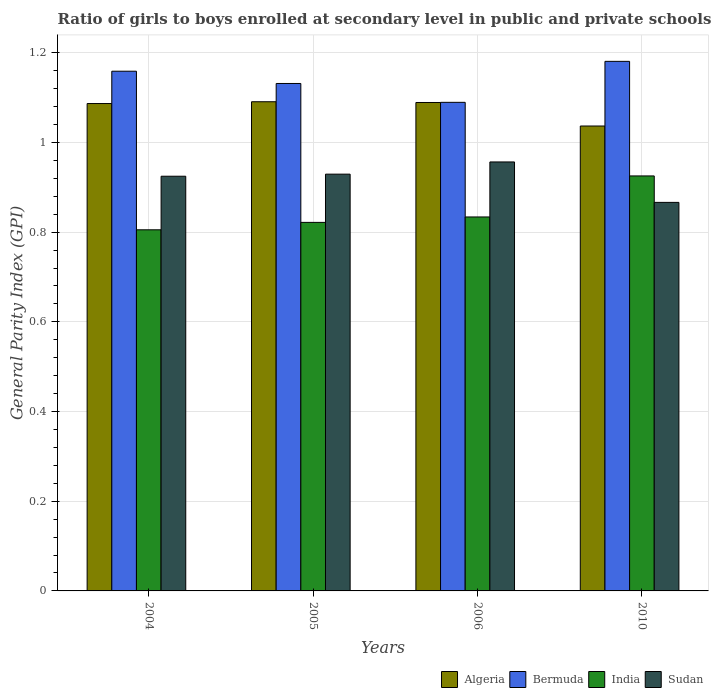How many groups of bars are there?
Offer a terse response. 4. Are the number of bars per tick equal to the number of legend labels?
Give a very brief answer. Yes. Are the number of bars on each tick of the X-axis equal?
Your answer should be very brief. Yes. How many bars are there on the 3rd tick from the left?
Give a very brief answer. 4. How many bars are there on the 1st tick from the right?
Keep it short and to the point. 4. What is the label of the 4th group of bars from the left?
Keep it short and to the point. 2010. In how many cases, is the number of bars for a given year not equal to the number of legend labels?
Keep it short and to the point. 0. What is the general parity index in India in 2010?
Make the answer very short. 0.93. Across all years, what is the maximum general parity index in India?
Provide a succinct answer. 0.93. Across all years, what is the minimum general parity index in Sudan?
Offer a very short reply. 0.87. In which year was the general parity index in Sudan maximum?
Your answer should be very brief. 2006. In which year was the general parity index in Sudan minimum?
Offer a very short reply. 2010. What is the total general parity index in India in the graph?
Provide a short and direct response. 3.39. What is the difference between the general parity index in Bermuda in 2005 and that in 2006?
Give a very brief answer. 0.04. What is the difference between the general parity index in Algeria in 2010 and the general parity index in Bermuda in 2005?
Provide a succinct answer. -0.09. What is the average general parity index in Sudan per year?
Offer a very short reply. 0.92. In the year 2010, what is the difference between the general parity index in India and general parity index in Bermuda?
Ensure brevity in your answer.  -0.26. In how many years, is the general parity index in Sudan greater than 0.7600000000000001?
Keep it short and to the point. 4. What is the ratio of the general parity index in Bermuda in 2004 to that in 2005?
Your answer should be very brief. 1.02. Is the general parity index in Bermuda in 2006 less than that in 2010?
Offer a terse response. Yes. What is the difference between the highest and the second highest general parity index in Bermuda?
Provide a succinct answer. 0.02. What is the difference between the highest and the lowest general parity index in India?
Your response must be concise. 0.12. In how many years, is the general parity index in Bermuda greater than the average general parity index in Bermuda taken over all years?
Offer a terse response. 2. Is the sum of the general parity index in Bermuda in 2005 and 2010 greater than the maximum general parity index in Algeria across all years?
Ensure brevity in your answer.  Yes. Is it the case that in every year, the sum of the general parity index in Sudan and general parity index in India is greater than the general parity index in Bermuda?
Keep it short and to the point. Yes. How many bars are there?
Offer a terse response. 16. Are all the bars in the graph horizontal?
Provide a short and direct response. No. Are the values on the major ticks of Y-axis written in scientific E-notation?
Ensure brevity in your answer.  No. Does the graph contain any zero values?
Offer a terse response. No. Does the graph contain grids?
Keep it short and to the point. Yes. How many legend labels are there?
Offer a very short reply. 4. How are the legend labels stacked?
Keep it short and to the point. Horizontal. What is the title of the graph?
Your answer should be very brief. Ratio of girls to boys enrolled at secondary level in public and private schools. Does "Bosnia and Herzegovina" appear as one of the legend labels in the graph?
Keep it short and to the point. No. What is the label or title of the X-axis?
Provide a succinct answer. Years. What is the label or title of the Y-axis?
Your answer should be compact. General Parity Index (GPI). What is the General Parity Index (GPI) in Algeria in 2004?
Make the answer very short. 1.09. What is the General Parity Index (GPI) in Bermuda in 2004?
Your answer should be very brief. 1.16. What is the General Parity Index (GPI) in India in 2004?
Offer a terse response. 0.81. What is the General Parity Index (GPI) of Sudan in 2004?
Ensure brevity in your answer.  0.92. What is the General Parity Index (GPI) of Algeria in 2005?
Provide a succinct answer. 1.09. What is the General Parity Index (GPI) of Bermuda in 2005?
Provide a short and direct response. 1.13. What is the General Parity Index (GPI) of India in 2005?
Ensure brevity in your answer.  0.82. What is the General Parity Index (GPI) in Sudan in 2005?
Provide a short and direct response. 0.93. What is the General Parity Index (GPI) in Algeria in 2006?
Offer a terse response. 1.09. What is the General Parity Index (GPI) in Bermuda in 2006?
Offer a very short reply. 1.09. What is the General Parity Index (GPI) in India in 2006?
Make the answer very short. 0.83. What is the General Parity Index (GPI) in Sudan in 2006?
Offer a terse response. 0.96. What is the General Parity Index (GPI) in Algeria in 2010?
Your answer should be compact. 1.04. What is the General Parity Index (GPI) in Bermuda in 2010?
Offer a very short reply. 1.18. What is the General Parity Index (GPI) of India in 2010?
Give a very brief answer. 0.93. What is the General Parity Index (GPI) in Sudan in 2010?
Your response must be concise. 0.87. Across all years, what is the maximum General Parity Index (GPI) of Algeria?
Your answer should be very brief. 1.09. Across all years, what is the maximum General Parity Index (GPI) in Bermuda?
Keep it short and to the point. 1.18. Across all years, what is the maximum General Parity Index (GPI) of India?
Provide a succinct answer. 0.93. Across all years, what is the maximum General Parity Index (GPI) in Sudan?
Provide a short and direct response. 0.96. Across all years, what is the minimum General Parity Index (GPI) in Algeria?
Ensure brevity in your answer.  1.04. Across all years, what is the minimum General Parity Index (GPI) in Bermuda?
Ensure brevity in your answer.  1.09. Across all years, what is the minimum General Parity Index (GPI) of India?
Provide a short and direct response. 0.81. Across all years, what is the minimum General Parity Index (GPI) of Sudan?
Make the answer very short. 0.87. What is the total General Parity Index (GPI) of Algeria in the graph?
Offer a very short reply. 4.3. What is the total General Parity Index (GPI) of Bermuda in the graph?
Make the answer very short. 4.56. What is the total General Parity Index (GPI) of India in the graph?
Provide a succinct answer. 3.39. What is the total General Parity Index (GPI) of Sudan in the graph?
Keep it short and to the point. 3.68. What is the difference between the General Parity Index (GPI) of Algeria in 2004 and that in 2005?
Make the answer very short. -0. What is the difference between the General Parity Index (GPI) of Bermuda in 2004 and that in 2005?
Provide a succinct answer. 0.03. What is the difference between the General Parity Index (GPI) in India in 2004 and that in 2005?
Your response must be concise. -0.02. What is the difference between the General Parity Index (GPI) in Sudan in 2004 and that in 2005?
Ensure brevity in your answer.  -0. What is the difference between the General Parity Index (GPI) of Algeria in 2004 and that in 2006?
Ensure brevity in your answer.  -0. What is the difference between the General Parity Index (GPI) in Bermuda in 2004 and that in 2006?
Your answer should be very brief. 0.07. What is the difference between the General Parity Index (GPI) of India in 2004 and that in 2006?
Your answer should be very brief. -0.03. What is the difference between the General Parity Index (GPI) of Sudan in 2004 and that in 2006?
Keep it short and to the point. -0.03. What is the difference between the General Parity Index (GPI) in Algeria in 2004 and that in 2010?
Provide a short and direct response. 0.05. What is the difference between the General Parity Index (GPI) in Bermuda in 2004 and that in 2010?
Provide a succinct answer. -0.02. What is the difference between the General Parity Index (GPI) of India in 2004 and that in 2010?
Make the answer very short. -0.12. What is the difference between the General Parity Index (GPI) in Sudan in 2004 and that in 2010?
Your answer should be compact. 0.06. What is the difference between the General Parity Index (GPI) in Algeria in 2005 and that in 2006?
Your answer should be very brief. 0. What is the difference between the General Parity Index (GPI) of Bermuda in 2005 and that in 2006?
Ensure brevity in your answer.  0.04. What is the difference between the General Parity Index (GPI) of India in 2005 and that in 2006?
Your answer should be compact. -0.01. What is the difference between the General Parity Index (GPI) in Sudan in 2005 and that in 2006?
Keep it short and to the point. -0.03. What is the difference between the General Parity Index (GPI) of Algeria in 2005 and that in 2010?
Give a very brief answer. 0.05. What is the difference between the General Parity Index (GPI) in Bermuda in 2005 and that in 2010?
Ensure brevity in your answer.  -0.05. What is the difference between the General Parity Index (GPI) in India in 2005 and that in 2010?
Ensure brevity in your answer.  -0.1. What is the difference between the General Parity Index (GPI) of Sudan in 2005 and that in 2010?
Your answer should be compact. 0.06. What is the difference between the General Parity Index (GPI) in Algeria in 2006 and that in 2010?
Provide a short and direct response. 0.05. What is the difference between the General Parity Index (GPI) of Bermuda in 2006 and that in 2010?
Offer a terse response. -0.09. What is the difference between the General Parity Index (GPI) of India in 2006 and that in 2010?
Your answer should be compact. -0.09. What is the difference between the General Parity Index (GPI) of Sudan in 2006 and that in 2010?
Provide a short and direct response. 0.09. What is the difference between the General Parity Index (GPI) of Algeria in 2004 and the General Parity Index (GPI) of Bermuda in 2005?
Offer a terse response. -0.04. What is the difference between the General Parity Index (GPI) in Algeria in 2004 and the General Parity Index (GPI) in India in 2005?
Keep it short and to the point. 0.27. What is the difference between the General Parity Index (GPI) in Algeria in 2004 and the General Parity Index (GPI) in Sudan in 2005?
Give a very brief answer. 0.16. What is the difference between the General Parity Index (GPI) of Bermuda in 2004 and the General Parity Index (GPI) of India in 2005?
Make the answer very short. 0.34. What is the difference between the General Parity Index (GPI) in Bermuda in 2004 and the General Parity Index (GPI) in Sudan in 2005?
Your response must be concise. 0.23. What is the difference between the General Parity Index (GPI) of India in 2004 and the General Parity Index (GPI) of Sudan in 2005?
Your answer should be compact. -0.12. What is the difference between the General Parity Index (GPI) of Algeria in 2004 and the General Parity Index (GPI) of Bermuda in 2006?
Your response must be concise. -0. What is the difference between the General Parity Index (GPI) of Algeria in 2004 and the General Parity Index (GPI) of India in 2006?
Ensure brevity in your answer.  0.25. What is the difference between the General Parity Index (GPI) in Algeria in 2004 and the General Parity Index (GPI) in Sudan in 2006?
Ensure brevity in your answer.  0.13. What is the difference between the General Parity Index (GPI) of Bermuda in 2004 and the General Parity Index (GPI) of India in 2006?
Ensure brevity in your answer.  0.33. What is the difference between the General Parity Index (GPI) in Bermuda in 2004 and the General Parity Index (GPI) in Sudan in 2006?
Provide a short and direct response. 0.2. What is the difference between the General Parity Index (GPI) of India in 2004 and the General Parity Index (GPI) of Sudan in 2006?
Offer a very short reply. -0.15. What is the difference between the General Parity Index (GPI) of Algeria in 2004 and the General Parity Index (GPI) of Bermuda in 2010?
Offer a very short reply. -0.09. What is the difference between the General Parity Index (GPI) in Algeria in 2004 and the General Parity Index (GPI) in India in 2010?
Give a very brief answer. 0.16. What is the difference between the General Parity Index (GPI) in Algeria in 2004 and the General Parity Index (GPI) in Sudan in 2010?
Your answer should be very brief. 0.22. What is the difference between the General Parity Index (GPI) in Bermuda in 2004 and the General Parity Index (GPI) in India in 2010?
Your response must be concise. 0.23. What is the difference between the General Parity Index (GPI) of Bermuda in 2004 and the General Parity Index (GPI) of Sudan in 2010?
Your answer should be compact. 0.29. What is the difference between the General Parity Index (GPI) in India in 2004 and the General Parity Index (GPI) in Sudan in 2010?
Make the answer very short. -0.06. What is the difference between the General Parity Index (GPI) in Algeria in 2005 and the General Parity Index (GPI) in Bermuda in 2006?
Your response must be concise. 0. What is the difference between the General Parity Index (GPI) in Algeria in 2005 and the General Parity Index (GPI) in India in 2006?
Provide a succinct answer. 0.26. What is the difference between the General Parity Index (GPI) of Algeria in 2005 and the General Parity Index (GPI) of Sudan in 2006?
Provide a short and direct response. 0.13. What is the difference between the General Parity Index (GPI) in Bermuda in 2005 and the General Parity Index (GPI) in India in 2006?
Offer a very short reply. 0.3. What is the difference between the General Parity Index (GPI) in Bermuda in 2005 and the General Parity Index (GPI) in Sudan in 2006?
Keep it short and to the point. 0.17. What is the difference between the General Parity Index (GPI) in India in 2005 and the General Parity Index (GPI) in Sudan in 2006?
Provide a succinct answer. -0.13. What is the difference between the General Parity Index (GPI) of Algeria in 2005 and the General Parity Index (GPI) of Bermuda in 2010?
Ensure brevity in your answer.  -0.09. What is the difference between the General Parity Index (GPI) in Algeria in 2005 and the General Parity Index (GPI) in India in 2010?
Provide a short and direct response. 0.17. What is the difference between the General Parity Index (GPI) in Algeria in 2005 and the General Parity Index (GPI) in Sudan in 2010?
Offer a terse response. 0.22. What is the difference between the General Parity Index (GPI) of Bermuda in 2005 and the General Parity Index (GPI) of India in 2010?
Give a very brief answer. 0.21. What is the difference between the General Parity Index (GPI) of Bermuda in 2005 and the General Parity Index (GPI) of Sudan in 2010?
Keep it short and to the point. 0.27. What is the difference between the General Parity Index (GPI) in India in 2005 and the General Parity Index (GPI) in Sudan in 2010?
Give a very brief answer. -0.04. What is the difference between the General Parity Index (GPI) of Algeria in 2006 and the General Parity Index (GPI) of Bermuda in 2010?
Keep it short and to the point. -0.09. What is the difference between the General Parity Index (GPI) in Algeria in 2006 and the General Parity Index (GPI) in India in 2010?
Offer a terse response. 0.16. What is the difference between the General Parity Index (GPI) of Algeria in 2006 and the General Parity Index (GPI) of Sudan in 2010?
Provide a short and direct response. 0.22. What is the difference between the General Parity Index (GPI) of Bermuda in 2006 and the General Parity Index (GPI) of India in 2010?
Keep it short and to the point. 0.16. What is the difference between the General Parity Index (GPI) of Bermuda in 2006 and the General Parity Index (GPI) of Sudan in 2010?
Provide a short and direct response. 0.22. What is the difference between the General Parity Index (GPI) of India in 2006 and the General Parity Index (GPI) of Sudan in 2010?
Your response must be concise. -0.03. What is the average General Parity Index (GPI) of Algeria per year?
Provide a succinct answer. 1.08. What is the average General Parity Index (GPI) in Bermuda per year?
Give a very brief answer. 1.14. What is the average General Parity Index (GPI) in India per year?
Keep it short and to the point. 0.85. What is the average General Parity Index (GPI) of Sudan per year?
Provide a succinct answer. 0.92. In the year 2004, what is the difference between the General Parity Index (GPI) of Algeria and General Parity Index (GPI) of Bermuda?
Give a very brief answer. -0.07. In the year 2004, what is the difference between the General Parity Index (GPI) in Algeria and General Parity Index (GPI) in India?
Provide a succinct answer. 0.28. In the year 2004, what is the difference between the General Parity Index (GPI) in Algeria and General Parity Index (GPI) in Sudan?
Offer a very short reply. 0.16. In the year 2004, what is the difference between the General Parity Index (GPI) in Bermuda and General Parity Index (GPI) in India?
Provide a short and direct response. 0.35. In the year 2004, what is the difference between the General Parity Index (GPI) of Bermuda and General Parity Index (GPI) of Sudan?
Your response must be concise. 0.23. In the year 2004, what is the difference between the General Parity Index (GPI) in India and General Parity Index (GPI) in Sudan?
Make the answer very short. -0.12. In the year 2005, what is the difference between the General Parity Index (GPI) of Algeria and General Parity Index (GPI) of Bermuda?
Your answer should be compact. -0.04. In the year 2005, what is the difference between the General Parity Index (GPI) of Algeria and General Parity Index (GPI) of India?
Offer a terse response. 0.27. In the year 2005, what is the difference between the General Parity Index (GPI) of Algeria and General Parity Index (GPI) of Sudan?
Your answer should be compact. 0.16. In the year 2005, what is the difference between the General Parity Index (GPI) of Bermuda and General Parity Index (GPI) of India?
Ensure brevity in your answer.  0.31. In the year 2005, what is the difference between the General Parity Index (GPI) of Bermuda and General Parity Index (GPI) of Sudan?
Ensure brevity in your answer.  0.2. In the year 2005, what is the difference between the General Parity Index (GPI) in India and General Parity Index (GPI) in Sudan?
Give a very brief answer. -0.11. In the year 2006, what is the difference between the General Parity Index (GPI) in Algeria and General Parity Index (GPI) in Bermuda?
Provide a short and direct response. -0. In the year 2006, what is the difference between the General Parity Index (GPI) of Algeria and General Parity Index (GPI) of India?
Give a very brief answer. 0.26. In the year 2006, what is the difference between the General Parity Index (GPI) of Algeria and General Parity Index (GPI) of Sudan?
Ensure brevity in your answer.  0.13. In the year 2006, what is the difference between the General Parity Index (GPI) of Bermuda and General Parity Index (GPI) of India?
Give a very brief answer. 0.26. In the year 2006, what is the difference between the General Parity Index (GPI) of Bermuda and General Parity Index (GPI) of Sudan?
Provide a succinct answer. 0.13. In the year 2006, what is the difference between the General Parity Index (GPI) of India and General Parity Index (GPI) of Sudan?
Provide a succinct answer. -0.12. In the year 2010, what is the difference between the General Parity Index (GPI) of Algeria and General Parity Index (GPI) of Bermuda?
Provide a succinct answer. -0.14. In the year 2010, what is the difference between the General Parity Index (GPI) of Algeria and General Parity Index (GPI) of India?
Your response must be concise. 0.11. In the year 2010, what is the difference between the General Parity Index (GPI) in Algeria and General Parity Index (GPI) in Sudan?
Offer a terse response. 0.17. In the year 2010, what is the difference between the General Parity Index (GPI) in Bermuda and General Parity Index (GPI) in India?
Your answer should be compact. 0.26. In the year 2010, what is the difference between the General Parity Index (GPI) in Bermuda and General Parity Index (GPI) in Sudan?
Your answer should be compact. 0.31. In the year 2010, what is the difference between the General Parity Index (GPI) in India and General Parity Index (GPI) in Sudan?
Keep it short and to the point. 0.06. What is the ratio of the General Parity Index (GPI) of Bermuda in 2004 to that in 2005?
Offer a terse response. 1.02. What is the ratio of the General Parity Index (GPI) of India in 2004 to that in 2005?
Give a very brief answer. 0.98. What is the ratio of the General Parity Index (GPI) in Algeria in 2004 to that in 2006?
Ensure brevity in your answer.  1. What is the ratio of the General Parity Index (GPI) in Bermuda in 2004 to that in 2006?
Provide a short and direct response. 1.06. What is the ratio of the General Parity Index (GPI) in India in 2004 to that in 2006?
Keep it short and to the point. 0.97. What is the ratio of the General Parity Index (GPI) in Sudan in 2004 to that in 2006?
Offer a very short reply. 0.97. What is the ratio of the General Parity Index (GPI) in Algeria in 2004 to that in 2010?
Offer a very short reply. 1.05. What is the ratio of the General Parity Index (GPI) of Bermuda in 2004 to that in 2010?
Make the answer very short. 0.98. What is the ratio of the General Parity Index (GPI) in India in 2004 to that in 2010?
Your answer should be compact. 0.87. What is the ratio of the General Parity Index (GPI) in Sudan in 2004 to that in 2010?
Give a very brief answer. 1.07. What is the ratio of the General Parity Index (GPI) of Bermuda in 2005 to that in 2006?
Give a very brief answer. 1.04. What is the ratio of the General Parity Index (GPI) in India in 2005 to that in 2006?
Offer a terse response. 0.99. What is the ratio of the General Parity Index (GPI) in Sudan in 2005 to that in 2006?
Your answer should be compact. 0.97. What is the ratio of the General Parity Index (GPI) in Algeria in 2005 to that in 2010?
Your answer should be compact. 1.05. What is the ratio of the General Parity Index (GPI) of Bermuda in 2005 to that in 2010?
Your answer should be compact. 0.96. What is the ratio of the General Parity Index (GPI) of India in 2005 to that in 2010?
Your response must be concise. 0.89. What is the ratio of the General Parity Index (GPI) in Sudan in 2005 to that in 2010?
Offer a terse response. 1.07. What is the ratio of the General Parity Index (GPI) of Algeria in 2006 to that in 2010?
Your answer should be compact. 1.05. What is the ratio of the General Parity Index (GPI) of Bermuda in 2006 to that in 2010?
Provide a succinct answer. 0.92. What is the ratio of the General Parity Index (GPI) in India in 2006 to that in 2010?
Make the answer very short. 0.9. What is the ratio of the General Parity Index (GPI) of Sudan in 2006 to that in 2010?
Your answer should be very brief. 1.1. What is the difference between the highest and the second highest General Parity Index (GPI) of Algeria?
Your answer should be very brief. 0. What is the difference between the highest and the second highest General Parity Index (GPI) in Bermuda?
Your answer should be compact. 0.02. What is the difference between the highest and the second highest General Parity Index (GPI) in India?
Provide a succinct answer. 0.09. What is the difference between the highest and the second highest General Parity Index (GPI) of Sudan?
Provide a short and direct response. 0.03. What is the difference between the highest and the lowest General Parity Index (GPI) in Algeria?
Your answer should be compact. 0.05. What is the difference between the highest and the lowest General Parity Index (GPI) in Bermuda?
Your answer should be compact. 0.09. What is the difference between the highest and the lowest General Parity Index (GPI) of India?
Keep it short and to the point. 0.12. What is the difference between the highest and the lowest General Parity Index (GPI) of Sudan?
Offer a very short reply. 0.09. 